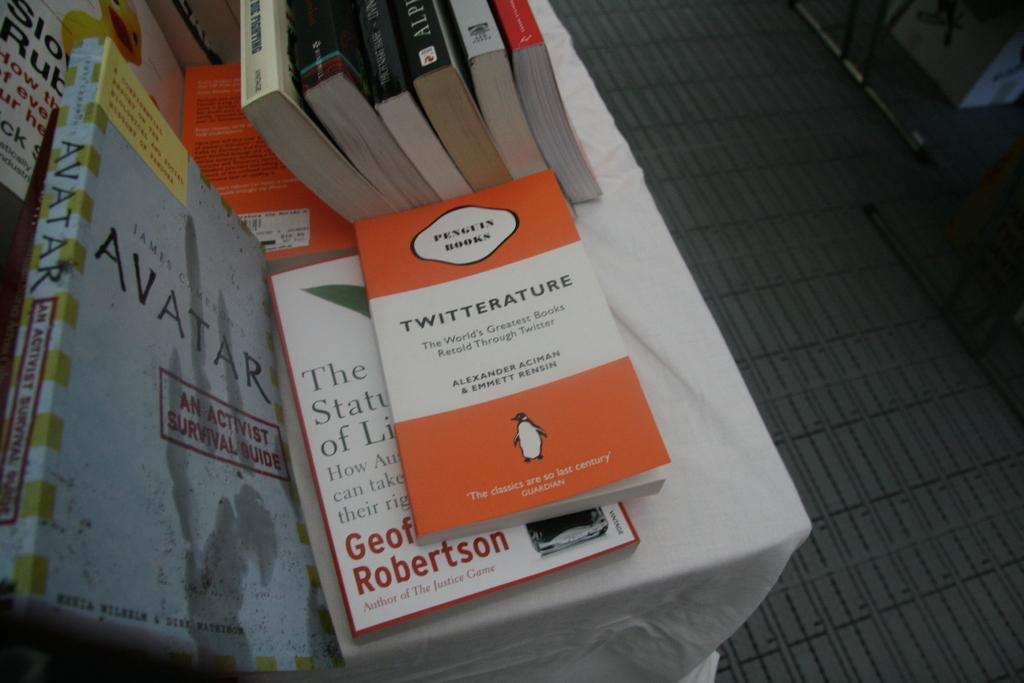<image>
Relay a brief, clear account of the picture shown. A copy of Twitterature from Penguin Books sits atop another book next to Avatar. 